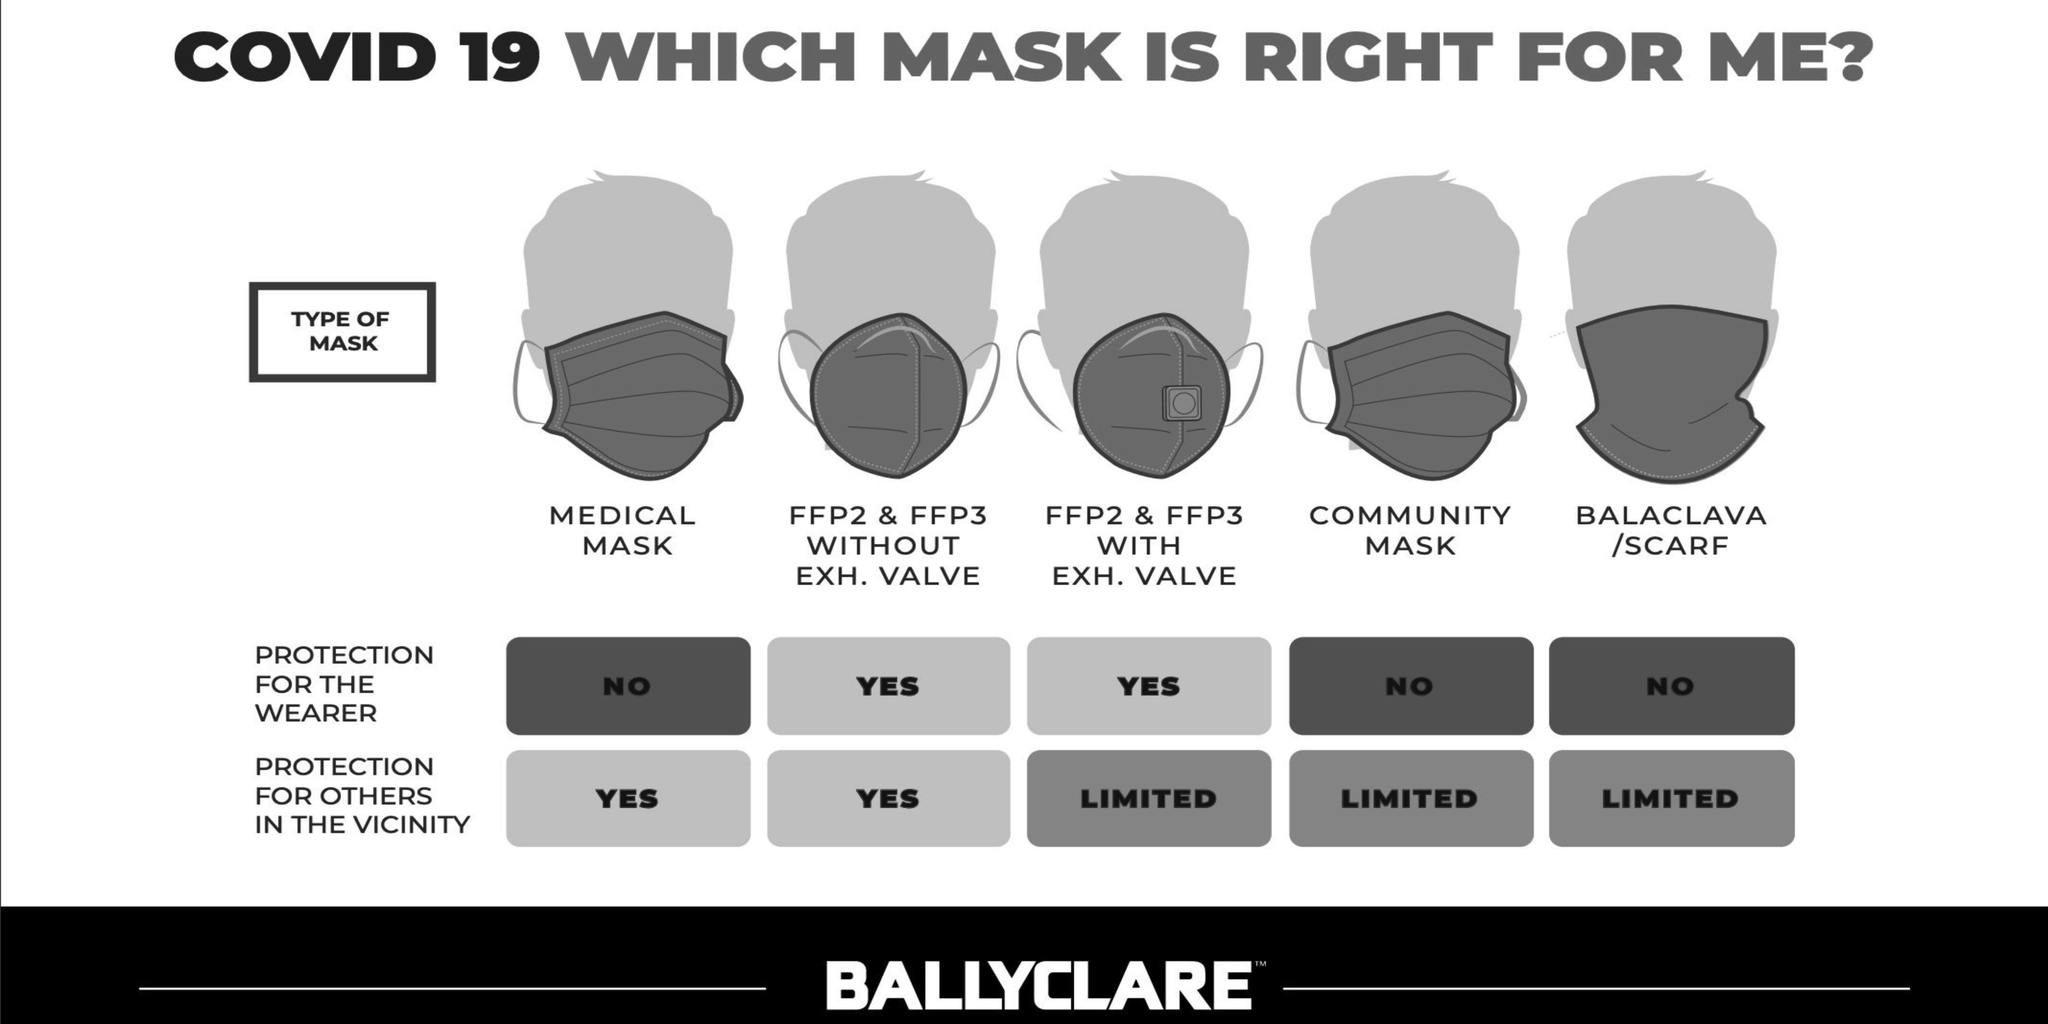Which mask doesn't offer good protection to the wearer and good protection to others in the vicinity
Answer the question with a short phrase. medical mask which mask offers the same protection as community mask balaclava / scarf Which mask offers good protection the wearer and limited protection for others FFP2 & FFP3 with Exh. Valve Which mask offers good protection to both the wearer and others in vicinity FFP2 & FFP3 without Exh. Valve 